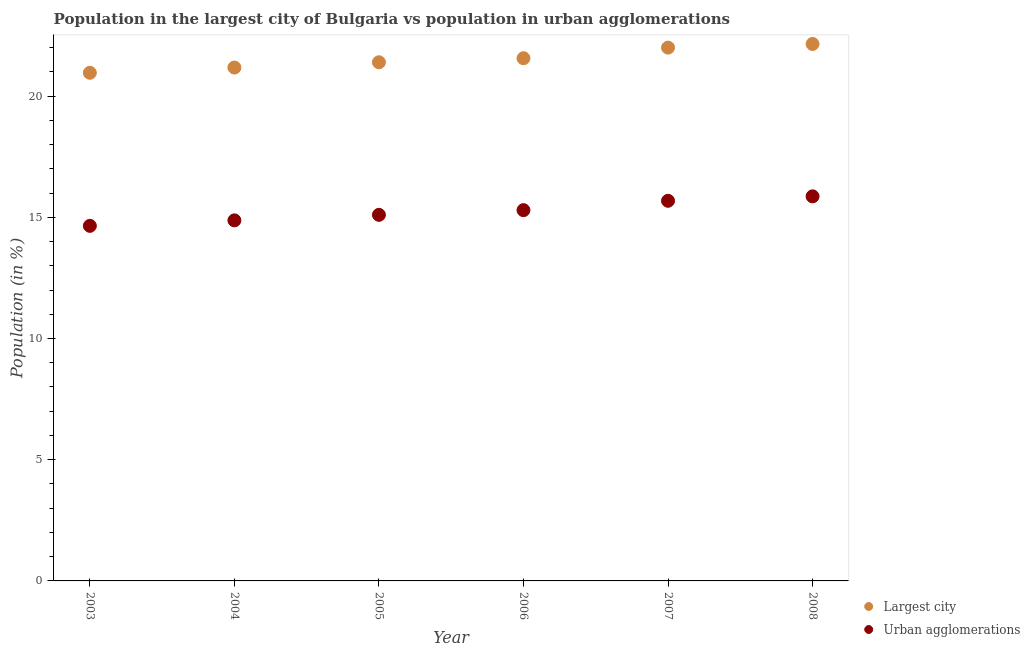Is the number of dotlines equal to the number of legend labels?
Keep it short and to the point. Yes. What is the population in urban agglomerations in 2005?
Provide a short and direct response. 15.1. Across all years, what is the maximum population in the largest city?
Offer a very short reply. 22.15. Across all years, what is the minimum population in the largest city?
Provide a succinct answer. 20.96. In which year was the population in urban agglomerations minimum?
Offer a terse response. 2003. What is the total population in the largest city in the graph?
Offer a very short reply. 129.25. What is the difference between the population in urban agglomerations in 2004 and that in 2005?
Provide a succinct answer. -0.23. What is the difference between the population in the largest city in 2003 and the population in urban agglomerations in 2004?
Offer a terse response. 6.09. What is the average population in urban agglomerations per year?
Ensure brevity in your answer.  15.24. In the year 2003, what is the difference between the population in the largest city and population in urban agglomerations?
Give a very brief answer. 6.31. In how many years, is the population in urban agglomerations greater than 18 %?
Ensure brevity in your answer.  0. What is the ratio of the population in urban agglomerations in 2006 to that in 2007?
Keep it short and to the point. 0.98. Is the population in the largest city in 2006 less than that in 2008?
Offer a terse response. Yes. Is the difference between the population in the largest city in 2005 and 2007 greater than the difference between the population in urban agglomerations in 2005 and 2007?
Ensure brevity in your answer.  No. What is the difference between the highest and the second highest population in urban agglomerations?
Offer a terse response. 0.18. What is the difference between the highest and the lowest population in urban agglomerations?
Your answer should be compact. 1.22. In how many years, is the population in urban agglomerations greater than the average population in urban agglomerations taken over all years?
Offer a terse response. 3. Is the population in urban agglomerations strictly greater than the population in the largest city over the years?
Provide a short and direct response. No. How many dotlines are there?
Provide a short and direct response. 2. How many years are there in the graph?
Make the answer very short. 6. What is the difference between two consecutive major ticks on the Y-axis?
Provide a short and direct response. 5. Does the graph contain any zero values?
Provide a short and direct response. No. What is the title of the graph?
Offer a very short reply. Population in the largest city of Bulgaria vs population in urban agglomerations. What is the label or title of the X-axis?
Provide a short and direct response. Year. What is the Population (in %) in Largest city in 2003?
Give a very brief answer. 20.96. What is the Population (in %) of Urban agglomerations in 2003?
Ensure brevity in your answer.  14.65. What is the Population (in %) in Largest city in 2004?
Offer a very short reply. 21.18. What is the Population (in %) in Urban agglomerations in 2004?
Provide a short and direct response. 14.87. What is the Population (in %) in Largest city in 2005?
Give a very brief answer. 21.4. What is the Population (in %) of Urban agglomerations in 2005?
Make the answer very short. 15.1. What is the Population (in %) in Largest city in 2006?
Keep it short and to the point. 21.56. What is the Population (in %) of Urban agglomerations in 2006?
Provide a succinct answer. 15.29. What is the Population (in %) in Largest city in 2007?
Make the answer very short. 22. What is the Population (in %) in Urban agglomerations in 2007?
Ensure brevity in your answer.  15.68. What is the Population (in %) of Largest city in 2008?
Your answer should be compact. 22.15. What is the Population (in %) of Urban agglomerations in 2008?
Offer a very short reply. 15.86. Across all years, what is the maximum Population (in %) of Largest city?
Your response must be concise. 22.15. Across all years, what is the maximum Population (in %) of Urban agglomerations?
Give a very brief answer. 15.86. Across all years, what is the minimum Population (in %) of Largest city?
Your answer should be compact. 20.96. Across all years, what is the minimum Population (in %) of Urban agglomerations?
Offer a very short reply. 14.65. What is the total Population (in %) in Largest city in the graph?
Keep it short and to the point. 129.25. What is the total Population (in %) in Urban agglomerations in the graph?
Ensure brevity in your answer.  91.46. What is the difference between the Population (in %) in Largest city in 2003 and that in 2004?
Your answer should be very brief. -0.22. What is the difference between the Population (in %) of Urban agglomerations in 2003 and that in 2004?
Give a very brief answer. -0.23. What is the difference between the Population (in %) in Largest city in 2003 and that in 2005?
Offer a terse response. -0.43. What is the difference between the Population (in %) of Urban agglomerations in 2003 and that in 2005?
Your answer should be compact. -0.45. What is the difference between the Population (in %) in Largest city in 2003 and that in 2006?
Offer a terse response. -0.6. What is the difference between the Population (in %) of Urban agglomerations in 2003 and that in 2006?
Keep it short and to the point. -0.65. What is the difference between the Population (in %) of Largest city in 2003 and that in 2007?
Ensure brevity in your answer.  -1.04. What is the difference between the Population (in %) in Urban agglomerations in 2003 and that in 2007?
Provide a short and direct response. -1.03. What is the difference between the Population (in %) of Largest city in 2003 and that in 2008?
Provide a short and direct response. -1.19. What is the difference between the Population (in %) in Urban agglomerations in 2003 and that in 2008?
Offer a terse response. -1.22. What is the difference between the Population (in %) of Largest city in 2004 and that in 2005?
Offer a terse response. -0.22. What is the difference between the Population (in %) of Urban agglomerations in 2004 and that in 2005?
Your response must be concise. -0.23. What is the difference between the Population (in %) of Largest city in 2004 and that in 2006?
Your response must be concise. -0.38. What is the difference between the Population (in %) in Urban agglomerations in 2004 and that in 2006?
Your answer should be compact. -0.42. What is the difference between the Population (in %) of Largest city in 2004 and that in 2007?
Provide a short and direct response. -0.82. What is the difference between the Population (in %) in Urban agglomerations in 2004 and that in 2007?
Offer a very short reply. -0.81. What is the difference between the Population (in %) in Largest city in 2004 and that in 2008?
Give a very brief answer. -0.97. What is the difference between the Population (in %) of Urban agglomerations in 2004 and that in 2008?
Your response must be concise. -0.99. What is the difference between the Population (in %) of Largest city in 2005 and that in 2006?
Ensure brevity in your answer.  -0.17. What is the difference between the Population (in %) of Urban agglomerations in 2005 and that in 2006?
Provide a short and direct response. -0.19. What is the difference between the Population (in %) of Largest city in 2005 and that in 2007?
Your response must be concise. -0.6. What is the difference between the Population (in %) in Urban agglomerations in 2005 and that in 2007?
Your answer should be compact. -0.58. What is the difference between the Population (in %) of Largest city in 2005 and that in 2008?
Give a very brief answer. -0.76. What is the difference between the Population (in %) in Urban agglomerations in 2005 and that in 2008?
Your answer should be very brief. -0.76. What is the difference between the Population (in %) in Largest city in 2006 and that in 2007?
Ensure brevity in your answer.  -0.44. What is the difference between the Population (in %) of Urban agglomerations in 2006 and that in 2007?
Your answer should be very brief. -0.39. What is the difference between the Population (in %) in Largest city in 2006 and that in 2008?
Provide a succinct answer. -0.59. What is the difference between the Population (in %) of Urban agglomerations in 2006 and that in 2008?
Make the answer very short. -0.57. What is the difference between the Population (in %) in Largest city in 2007 and that in 2008?
Give a very brief answer. -0.15. What is the difference between the Population (in %) of Urban agglomerations in 2007 and that in 2008?
Your response must be concise. -0.18. What is the difference between the Population (in %) of Largest city in 2003 and the Population (in %) of Urban agglomerations in 2004?
Ensure brevity in your answer.  6.09. What is the difference between the Population (in %) of Largest city in 2003 and the Population (in %) of Urban agglomerations in 2005?
Your answer should be compact. 5.86. What is the difference between the Population (in %) of Largest city in 2003 and the Population (in %) of Urban agglomerations in 2006?
Give a very brief answer. 5.67. What is the difference between the Population (in %) in Largest city in 2003 and the Population (in %) in Urban agglomerations in 2007?
Keep it short and to the point. 5.28. What is the difference between the Population (in %) in Largest city in 2003 and the Population (in %) in Urban agglomerations in 2008?
Provide a succinct answer. 5.1. What is the difference between the Population (in %) of Largest city in 2004 and the Population (in %) of Urban agglomerations in 2005?
Give a very brief answer. 6.08. What is the difference between the Population (in %) of Largest city in 2004 and the Population (in %) of Urban agglomerations in 2006?
Give a very brief answer. 5.88. What is the difference between the Population (in %) of Largest city in 2004 and the Population (in %) of Urban agglomerations in 2007?
Your response must be concise. 5.5. What is the difference between the Population (in %) in Largest city in 2004 and the Population (in %) in Urban agglomerations in 2008?
Give a very brief answer. 5.31. What is the difference between the Population (in %) of Largest city in 2005 and the Population (in %) of Urban agglomerations in 2006?
Offer a terse response. 6.1. What is the difference between the Population (in %) in Largest city in 2005 and the Population (in %) in Urban agglomerations in 2007?
Provide a succinct answer. 5.71. What is the difference between the Population (in %) of Largest city in 2005 and the Population (in %) of Urban agglomerations in 2008?
Provide a short and direct response. 5.53. What is the difference between the Population (in %) in Largest city in 2006 and the Population (in %) in Urban agglomerations in 2007?
Provide a succinct answer. 5.88. What is the difference between the Population (in %) of Largest city in 2006 and the Population (in %) of Urban agglomerations in 2008?
Provide a succinct answer. 5.7. What is the difference between the Population (in %) of Largest city in 2007 and the Population (in %) of Urban agglomerations in 2008?
Your answer should be compact. 6.14. What is the average Population (in %) in Largest city per year?
Keep it short and to the point. 21.54. What is the average Population (in %) of Urban agglomerations per year?
Your response must be concise. 15.24. In the year 2003, what is the difference between the Population (in %) of Largest city and Population (in %) of Urban agglomerations?
Ensure brevity in your answer.  6.31. In the year 2004, what is the difference between the Population (in %) of Largest city and Population (in %) of Urban agglomerations?
Offer a terse response. 6.3. In the year 2005, what is the difference between the Population (in %) in Largest city and Population (in %) in Urban agglomerations?
Keep it short and to the point. 6.29. In the year 2006, what is the difference between the Population (in %) of Largest city and Population (in %) of Urban agglomerations?
Your response must be concise. 6.27. In the year 2007, what is the difference between the Population (in %) of Largest city and Population (in %) of Urban agglomerations?
Make the answer very short. 6.32. In the year 2008, what is the difference between the Population (in %) in Largest city and Population (in %) in Urban agglomerations?
Provide a succinct answer. 6.29. What is the ratio of the Population (in %) in Urban agglomerations in 2003 to that in 2004?
Ensure brevity in your answer.  0.98. What is the ratio of the Population (in %) in Largest city in 2003 to that in 2005?
Make the answer very short. 0.98. What is the ratio of the Population (in %) in Urban agglomerations in 2003 to that in 2005?
Ensure brevity in your answer.  0.97. What is the ratio of the Population (in %) in Largest city in 2003 to that in 2006?
Provide a short and direct response. 0.97. What is the ratio of the Population (in %) of Urban agglomerations in 2003 to that in 2006?
Give a very brief answer. 0.96. What is the ratio of the Population (in %) in Largest city in 2003 to that in 2007?
Make the answer very short. 0.95. What is the ratio of the Population (in %) in Urban agglomerations in 2003 to that in 2007?
Your answer should be very brief. 0.93. What is the ratio of the Population (in %) of Largest city in 2003 to that in 2008?
Ensure brevity in your answer.  0.95. What is the ratio of the Population (in %) in Urban agglomerations in 2003 to that in 2008?
Provide a short and direct response. 0.92. What is the ratio of the Population (in %) in Largest city in 2004 to that in 2005?
Provide a short and direct response. 0.99. What is the ratio of the Population (in %) of Urban agglomerations in 2004 to that in 2005?
Offer a very short reply. 0.98. What is the ratio of the Population (in %) in Largest city in 2004 to that in 2006?
Offer a terse response. 0.98. What is the ratio of the Population (in %) in Urban agglomerations in 2004 to that in 2006?
Your answer should be compact. 0.97. What is the ratio of the Population (in %) in Largest city in 2004 to that in 2007?
Offer a very short reply. 0.96. What is the ratio of the Population (in %) of Urban agglomerations in 2004 to that in 2007?
Offer a terse response. 0.95. What is the ratio of the Population (in %) in Largest city in 2004 to that in 2008?
Offer a very short reply. 0.96. What is the ratio of the Population (in %) in Urban agglomerations in 2004 to that in 2008?
Provide a short and direct response. 0.94. What is the ratio of the Population (in %) in Largest city in 2005 to that in 2006?
Your answer should be very brief. 0.99. What is the ratio of the Population (in %) in Urban agglomerations in 2005 to that in 2006?
Offer a terse response. 0.99. What is the ratio of the Population (in %) of Largest city in 2005 to that in 2007?
Offer a very short reply. 0.97. What is the ratio of the Population (in %) in Largest city in 2005 to that in 2008?
Provide a short and direct response. 0.97. What is the ratio of the Population (in %) of Urban agglomerations in 2005 to that in 2008?
Provide a short and direct response. 0.95. What is the ratio of the Population (in %) in Largest city in 2006 to that in 2007?
Give a very brief answer. 0.98. What is the ratio of the Population (in %) in Urban agglomerations in 2006 to that in 2007?
Your answer should be compact. 0.98. What is the ratio of the Population (in %) of Largest city in 2006 to that in 2008?
Provide a short and direct response. 0.97. What is the ratio of the Population (in %) of Urban agglomerations in 2006 to that in 2008?
Your answer should be very brief. 0.96. What is the ratio of the Population (in %) of Urban agglomerations in 2007 to that in 2008?
Offer a very short reply. 0.99. What is the difference between the highest and the second highest Population (in %) in Largest city?
Your response must be concise. 0.15. What is the difference between the highest and the second highest Population (in %) in Urban agglomerations?
Provide a short and direct response. 0.18. What is the difference between the highest and the lowest Population (in %) in Largest city?
Your answer should be compact. 1.19. What is the difference between the highest and the lowest Population (in %) of Urban agglomerations?
Your answer should be compact. 1.22. 